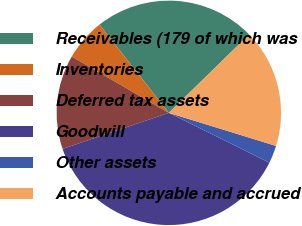<chart> <loc_0><loc_0><loc_500><loc_500><pie_chart><fcel>Receivables (179 of which was<fcel>Inventories<fcel>Deferred tax assets<fcel>Goodwill<fcel>Other assets<fcel>Accounts payable and accrued<nl><fcel>23.29%<fcel>6.04%<fcel>13.57%<fcel>37.48%<fcel>2.55%<fcel>17.07%<nl></chart> 